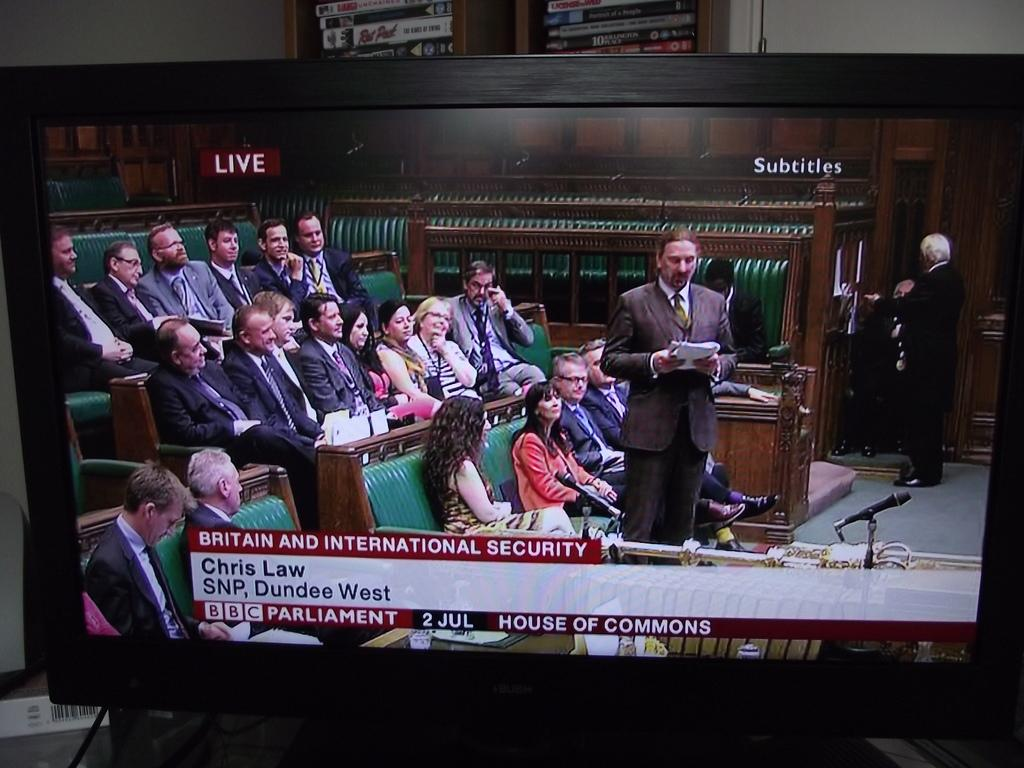<image>
Give a short and clear explanation of the subsequent image. A TV is showing a hearing in the British Parliament House of Commons and it says Live in the corner of the screen. 